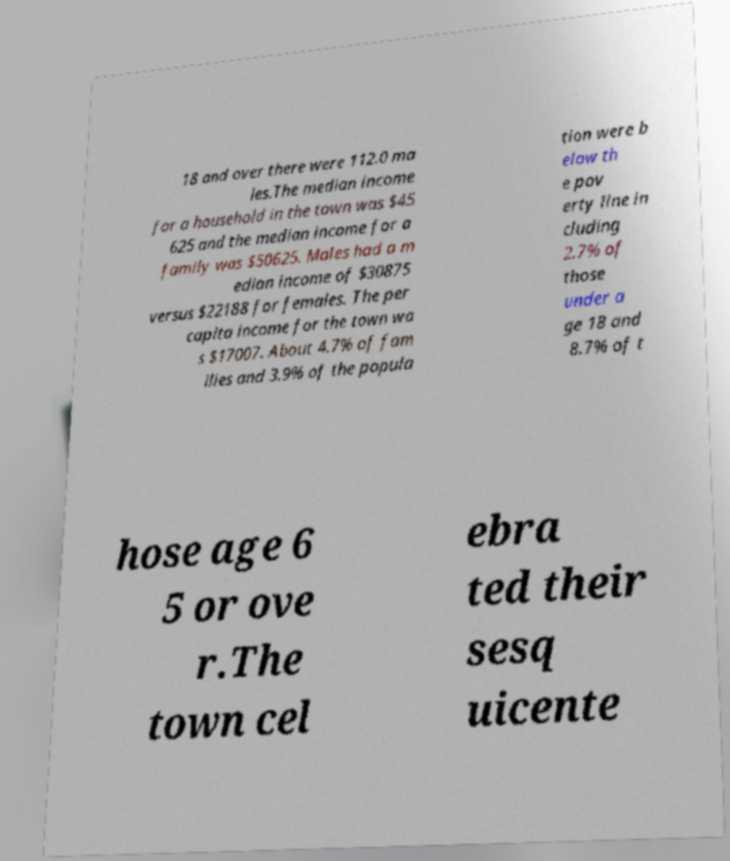Could you extract and type out the text from this image? 18 and over there were 112.0 ma les.The median income for a household in the town was $45 625 and the median income for a family was $50625. Males had a m edian income of $30875 versus $22188 for females. The per capita income for the town wa s $17007. About 4.7% of fam ilies and 3.9% of the popula tion were b elow th e pov erty line in cluding 2.7% of those under a ge 18 and 8.7% of t hose age 6 5 or ove r.The town cel ebra ted their sesq uicente 